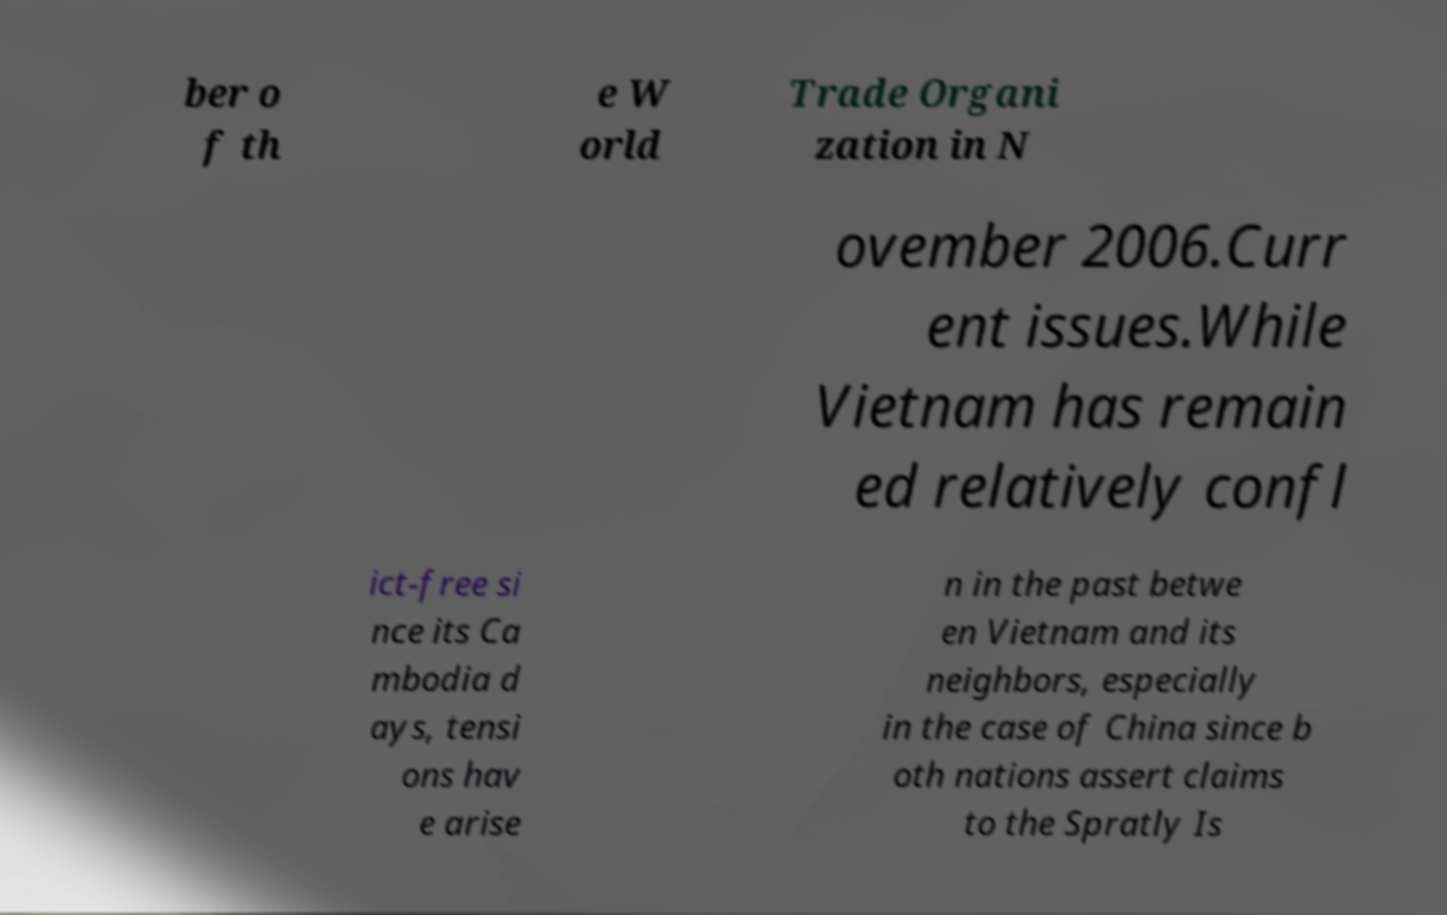What messages or text are displayed in this image? I need them in a readable, typed format. ber o f th e W orld Trade Organi zation in N ovember 2006.Curr ent issues.While Vietnam has remain ed relatively confl ict-free si nce its Ca mbodia d ays, tensi ons hav e arise n in the past betwe en Vietnam and its neighbors, especially in the case of China since b oth nations assert claims to the Spratly Is 